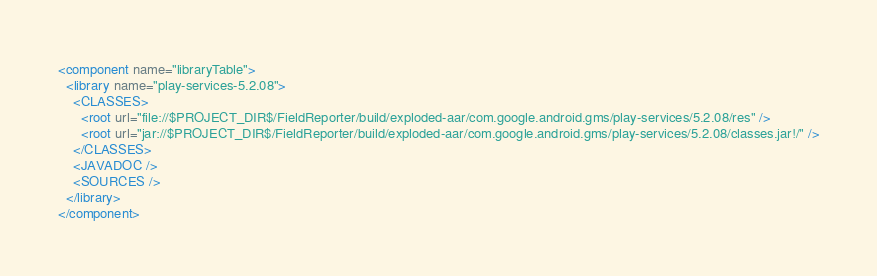Convert code to text. <code><loc_0><loc_0><loc_500><loc_500><_XML_><component name="libraryTable">
  <library name="play-services-5.2.08">
    <CLASSES>
      <root url="file://$PROJECT_DIR$/FieldReporter/build/exploded-aar/com.google.android.gms/play-services/5.2.08/res" />
      <root url="jar://$PROJECT_DIR$/FieldReporter/build/exploded-aar/com.google.android.gms/play-services/5.2.08/classes.jar!/" />
    </CLASSES>
    <JAVADOC />
    <SOURCES />
  </library>
</component></code> 